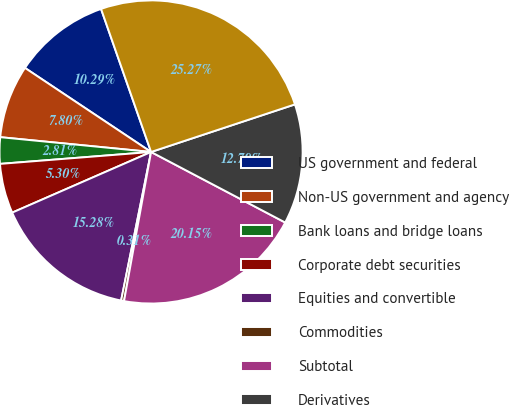Convert chart. <chart><loc_0><loc_0><loc_500><loc_500><pie_chart><fcel>US government and federal<fcel>Non-US government and agency<fcel>Bank loans and bridge loans<fcel>Corporate debt securities<fcel>Equities and convertible<fcel>Commodities<fcel>Subtotal<fcel>Derivatives<fcel>Total<nl><fcel>10.29%<fcel>7.8%<fcel>2.81%<fcel>5.3%<fcel>15.28%<fcel>0.31%<fcel>20.15%<fcel>12.79%<fcel>25.27%<nl></chart> 